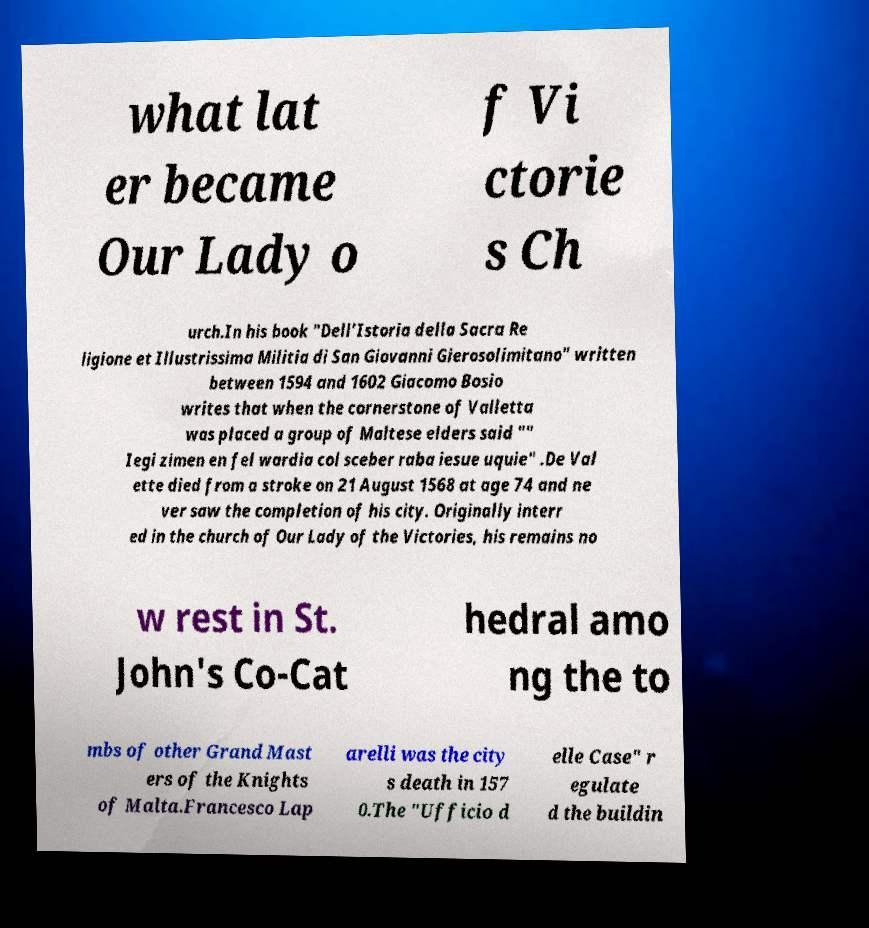Please identify and transcribe the text found in this image. what lat er became Our Lady o f Vi ctorie s Ch urch.In his book "Dell’Istoria della Sacra Re ligione et Illustrissima Militia di San Giovanni Gierosolimitano" written between 1594 and 1602 Giacomo Bosio writes that when the cornerstone of Valletta was placed a group of Maltese elders said "" Iegi zimen en fel wardia col sceber raba iesue uquie" .De Val ette died from a stroke on 21 August 1568 at age 74 and ne ver saw the completion of his city. Originally interr ed in the church of Our Lady of the Victories, his remains no w rest in St. John's Co-Cat hedral amo ng the to mbs of other Grand Mast ers of the Knights of Malta.Francesco Lap arelli was the city s death in 157 0.The "Ufficio d elle Case" r egulate d the buildin 